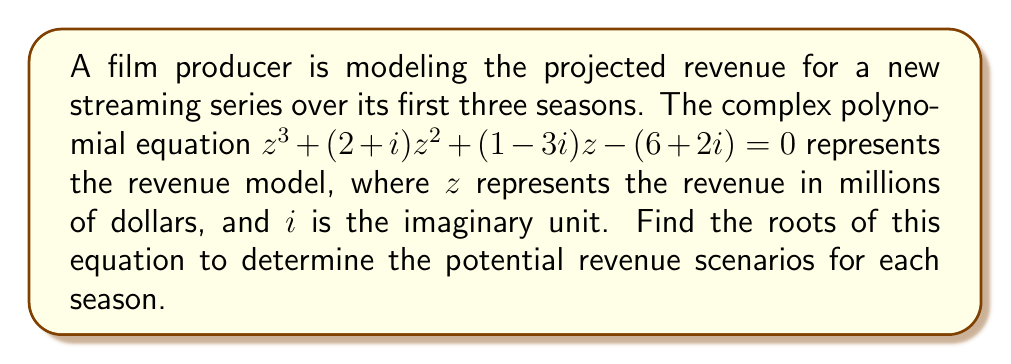What is the answer to this math problem? To solve this cubic equation, we'll use the following steps:

1) First, we need to identify the coefficients:
   $a = 1$
   $b = 2+i$
   $c = 1-3i$
   $d = -(6+2i)$

2) We'll use Cardano's formula for solving cubic equations. Let's define:
   $p = \frac{3ac-b^2}{3a^2}$
   $q = \frac{2b^3-9abc+27a^2d}{27a^3}$

3) Calculate $p$:
   $p = \frac{3(1)(1-3i)-(2+i)^2}{3(1)^2}$
   $p = \frac{3-9i-(4+4i+i^2)}{3}$
   $p = \frac{3-9i-(4+4i+(-1))}{3}$
   $p = \frac{-2-13i}{3}$

4) Calculate $q$:
   $q = \frac{2(2+i)^3-9(1)(2+i)(1-3i)+27(1)^2(-(6+2i))}{27(1)^3}$
   $q = \frac{2(8+12i-1)-9(2+i-6i-3i^2)-27(6+2i)}{27}$
   $q = \frac{14+24i-9(2+i+6+3)-27(6+2i)}{27}$
   $q = \frac{14+24i-99-162-54i}{27}$
   $q = \frac{-247-30i}{27}$

5) Now, we need to calculate:
   $u = \sqrt[3]{-\frac{q}{2}+\sqrt{\frac{q^2}{4}+\frac{p^3}{27}}}$
   $v = \sqrt[3]{-\frac{q}{2}-\sqrt{\frac{q^2}{4}+\frac{p^3}{27}}}$

6) The roots are given by:
   $z_1 = u + v - \frac{b}{3a}$
   $z_2 = -\frac{u+v}{2} - \frac{b}{3a} + i\frac{\sqrt{3}}{2}(u-v)$
   $z_3 = -\frac{u+v}{2} - \frac{b}{3a} - i\frac{\sqrt{3}}{2}(u-v)$

7) Calculating these values numerically (which would typically be done with a computer):
   $z_1 \approx 2.5 + 0.5i$
   $z_2 \approx -1.25 - 1.37i$
   $z_3 \approx -1.25 + 0.87i$

These complex roots represent the potential revenue scenarios for each season in millions of dollars.
Answer: $z_1 \approx 2.5 + 0.5i$, $z_2 \approx -1.25 - 1.37i$, $z_3 \approx -1.25 + 0.87i$ 